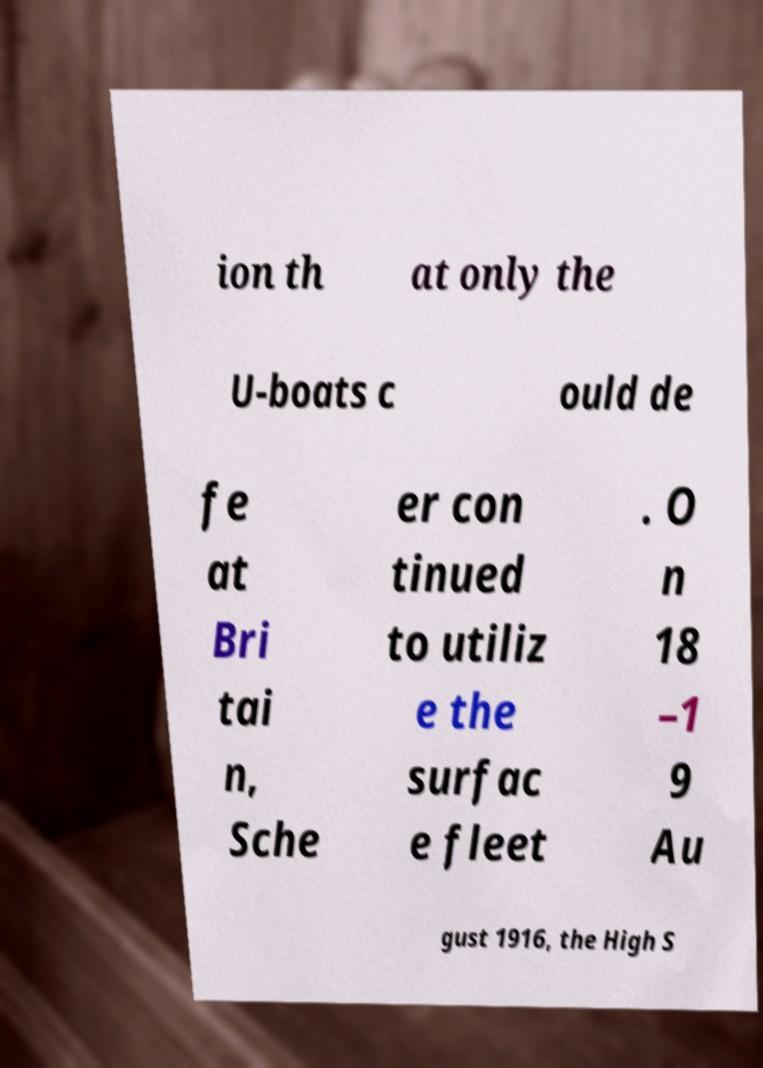Please identify and transcribe the text found in this image. ion th at only the U-boats c ould de fe at Bri tai n, Sche er con tinued to utiliz e the surfac e fleet . O n 18 –1 9 Au gust 1916, the High S 